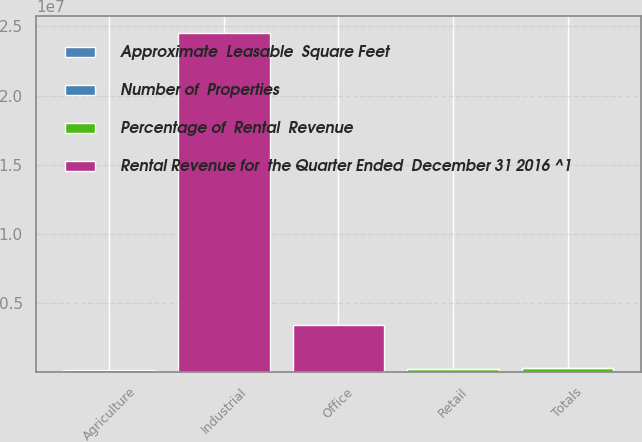Convert chart to OTSL. <chart><loc_0><loc_0><loc_500><loc_500><stacked_bar_chart><ecel><fcel>Retail<fcel>Industrial<fcel>Office<fcel>Agriculture<fcel>Totals<nl><fcel>Approximate  Leasable  Square Feet<fcel>4774<fcel>111<fcel>44<fcel>15<fcel>4944<nl><fcel>Rental Revenue for  the Quarter Ended  December 31 2016 ^1<fcel>4859<fcel>2.44521e+07<fcel>3.4032e+06<fcel>184500<fcel>4859<nl><fcel>Percentage of  Rental  Revenue<fcel>216904<fcel>36383<fcel>15111<fcel>6503<fcel>274901<nl><fcel>Number of  Properties<fcel>78.9<fcel>13.2<fcel>5.5<fcel>2.4<fcel>100<nl></chart> 